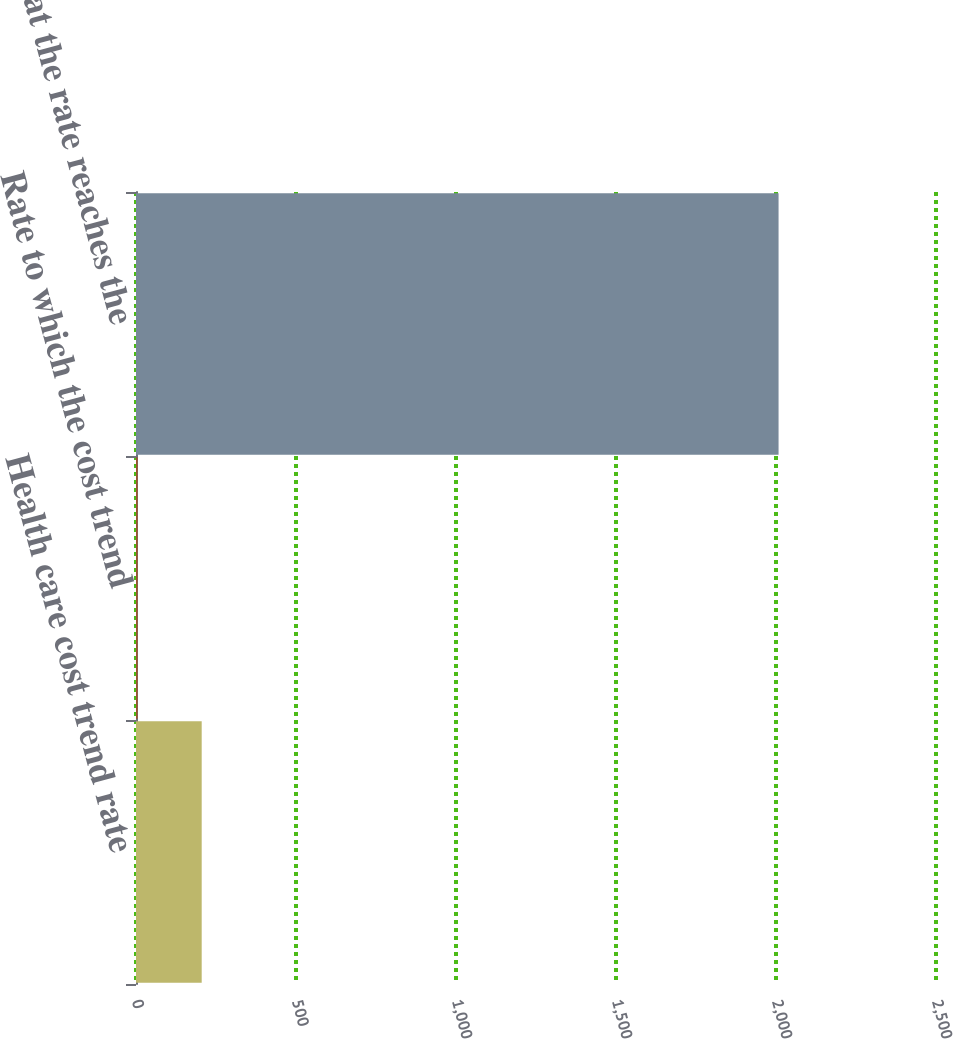Convert chart to OTSL. <chart><loc_0><loc_0><loc_500><loc_500><bar_chart><fcel>Health care cost trend rate<fcel>Rate to which the cost trend<fcel>Year that the rate reaches the<nl><fcel>205.3<fcel>5<fcel>2008<nl></chart> 